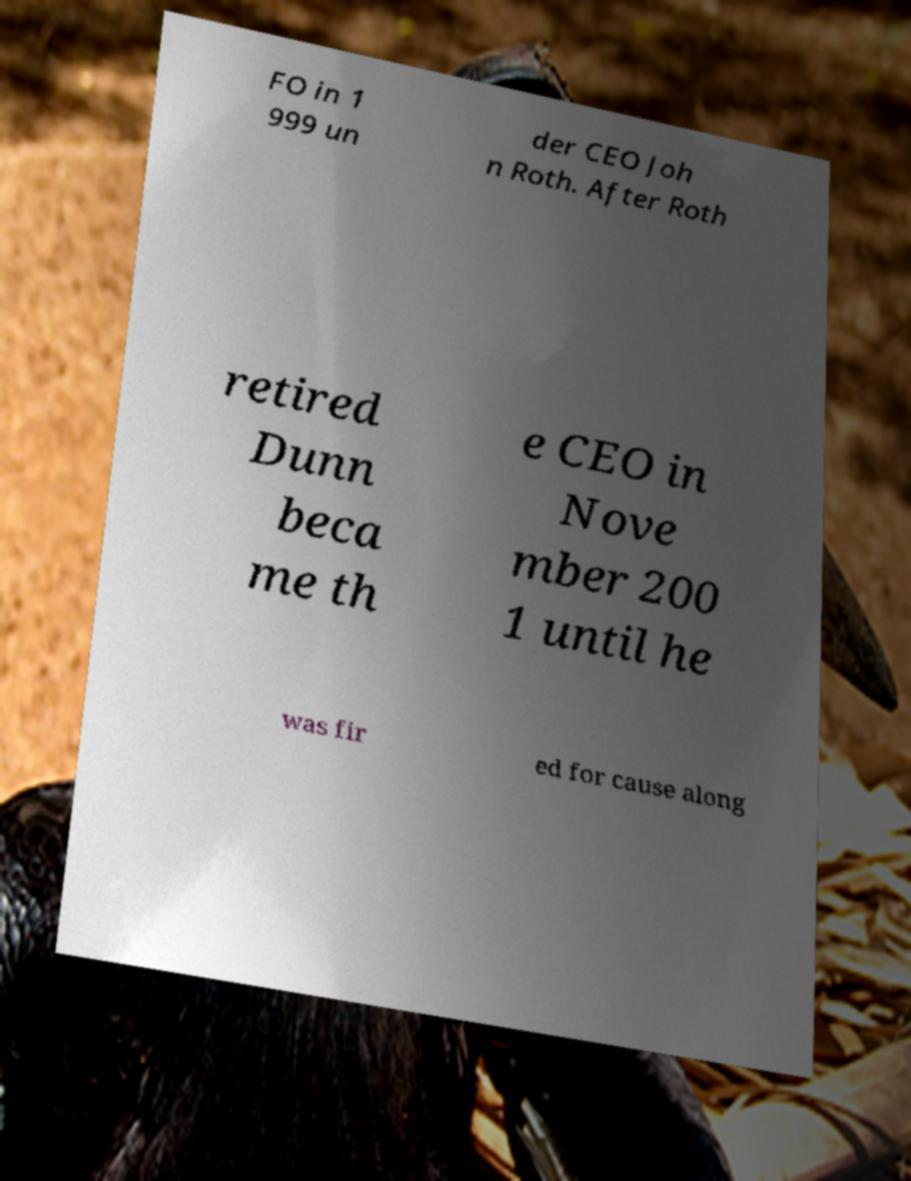Can you accurately transcribe the text from the provided image for me? FO in 1 999 un der CEO Joh n Roth. After Roth retired Dunn beca me th e CEO in Nove mber 200 1 until he was fir ed for cause along 